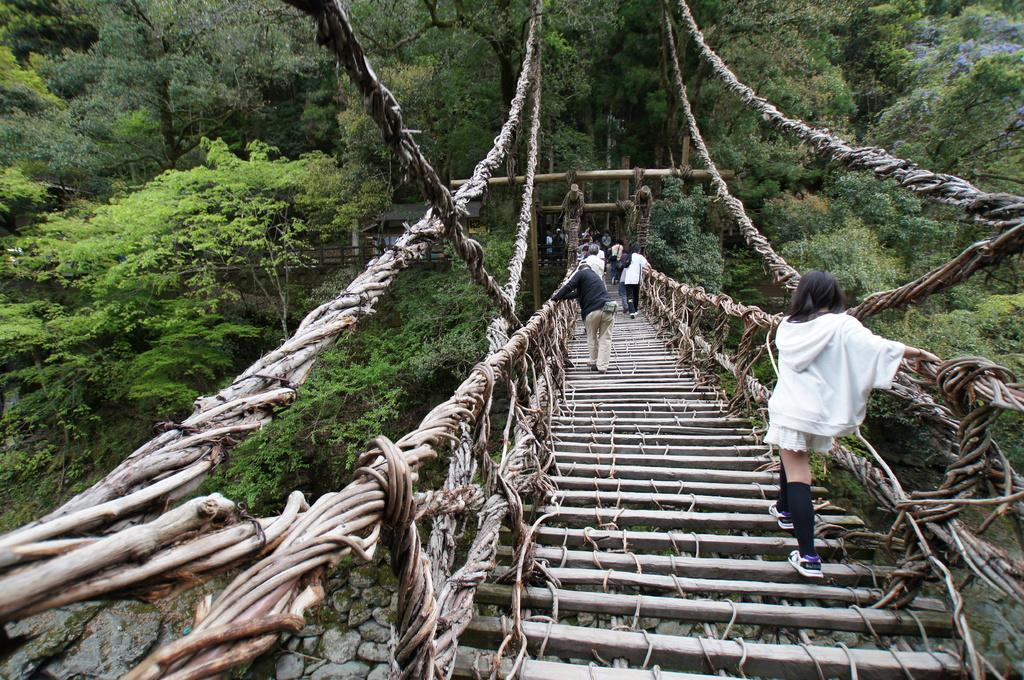What structure is depicted in the image? There is a bridge in the image. What are the people in the image doing? People are walking on the bridge. What can be seen in the background of the image? There are trees, plants, stones, a shed, and rod fencing visible in the background of the image. How many frogs are sitting on the bridge in the image? There are no frogs present in the image; it features a bridge with people walking on it. What type of humor can be seen in the image? There is no humor depicted in the image; it is a straightforward scene of a bridge and people walking on it. 